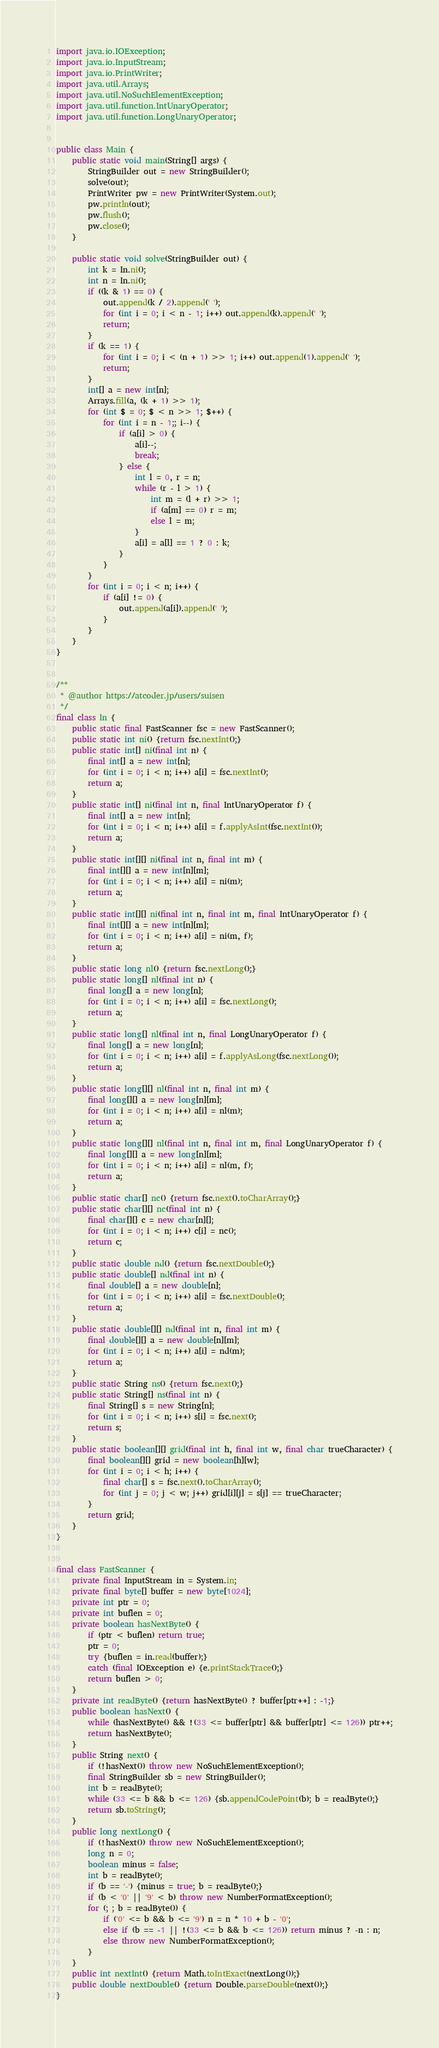Convert code to text. <code><loc_0><loc_0><loc_500><loc_500><_Java_>import java.io.IOException;
import java.io.InputStream;
import java.io.PrintWriter;
import java.util.Arrays;
import java.util.NoSuchElementException;
import java.util.function.IntUnaryOperator;
import java.util.function.LongUnaryOperator;


public class Main {
    public static void main(String[] args) {
        StringBuilder out = new StringBuilder();
        solve(out);
        PrintWriter pw = new PrintWriter(System.out);
        pw.println(out);
        pw.flush();
        pw.close();
    }

    public static void solve(StringBuilder out) {
        int k = In.ni();
        int n = In.ni();
        if ((k & 1) == 0) {
            out.append(k / 2).append(' ');
            for (int i = 0; i < n - 1; i++) out.append(k).append(' ');
            return;
        }
        if (k == 1) {
            for (int i = 0; i < (n + 1) >> 1; i++) out.append(1).append(' ');
            return;
        }
        int[] a = new int[n];
        Arrays.fill(a, (k + 1) >> 1);
        for (int $ = 0; $ < n >> 1; $++) {
            for (int i = n - 1;; i--) {
                if (a[i] > 0) {
                    a[i]--;
                    break;
                } else {
                    int l = 0, r = n;
                    while (r - l > 1) {
                        int m = (l + r) >> 1;
                        if (a[m] == 0) r = m;
                        else l = m;
                    }
                    a[i] = a[l] == 1 ? 0 : k;
                }
            }
        }
        for (int i = 0; i < n; i++) {
            if (a[i] != 0) {
                out.append(a[i]).append(' ');
            }
        }
    }
}


/**
 * @author https://atcoder.jp/users/suisen
 */
final class In {
    public static final FastScanner fsc = new FastScanner();
    public static int ni() {return fsc.nextInt();}
    public static int[] ni(final int n) {
        final int[] a = new int[n];
        for (int i = 0; i < n; i++) a[i] = fsc.nextInt();
        return a;
    }
    public static int[] ni(final int n, final IntUnaryOperator f) {
        final int[] a = new int[n];
        for (int i = 0; i < n; i++) a[i] = f.applyAsInt(fsc.nextInt());
        return a;
    }
    public static int[][] ni(final int n, final int m) {
        final int[][] a = new int[n][m];
        for (int i = 0; i < n; i++) a[i] = ni(m);
        return a;
    }
    public static int[][] ni(final int n, final int m, final IntUnaryOperator f) {
        final int[][] a = new int[n][m];
        for (int i = 0; i < n; i++) a[i] = ni(m, f);
        return a;
    }
    public static long nl() {return fsc.nextLong();}
    public static long[] nl(final int n) {
        final long[] a = new long[n];
        for (int i = 0; i < n; i++) a[i] = fsc.nextLong();
        return a;
    }
    public static long[] nl(final int n, final LongUnaryOperator f) {
        final long[] a = new long[n];
        for (int i = 0; i < n; i++) a[i] = f.applyAsLong(fsc.nextLong());
        return a;
    }
    public static long[][] nl(final int n, final int m) {
        final long[][] a = new long[n][m];
        for (int i = 0; i < n; i++) a[i] = nl(m);
        return a;
    }
    public static long[][] nl(final int n, final int m, final LongUnaryOperator f) {
        final long[][] a = new long[n][m];
        for (int i = 0; i < n; i++) a[i] = nl(m, f);
        return a;
    }
    public static char[] nc() {return fsc.next().toCharArray();}
    public static char[][] nc(final int n) {
        final char[][] c = new char[n][];
        for (int i = 0; i < n; i++) c[i] = nc();
        return c;
    }
    public static double nd() {return fsc.nextDouble();}
    public static double[] nd(final int n) {
        final double[] a = new double[n];
        for (int i = 0; i < n; i++) a[i] = fsc.nextDouble();
        return a;
    }
    public static double[][] nd(final int n, final int m) {
        final double[][] a = new double[n][m];
        for (int i = 0; i < n; i++) a[i] = nd(m);
        return a;
    }
    public static String ns() {return fsc.next();}
    public static String[] ns(final int n) {
        final String[] s = new String[n];
        for (int i = 0; i < n; i++) s[i] = fsc.next();
        return s;
    }
    public static boolean[][] grid(final int h, final int w, final char trueCharacter) {
        final boolean[][] grid = new boolean[h][w];
        for (int i = 0; i < h; i++) {
            final char[] s = fsc.next().toCharArray();
            for (int j = 0; j < w; j++) grid[i][j] = s[j] == trueCharacter;
        }
        return grid;
    }
}


final class FastScanner {
    private final InputStream in = System.in;
    private final byte[] buffer = new byte[1024];
    private int ptr = 0;
    private int buflen = 0;
    private boolean hasNextByte() {
        if (ptr < buflen) return true;
        ptr = 0;
        try {buflen = in.read(buffer);}
        catch (final IOException e) {e.printStackTrace();}
        return buflen > 0;
    }
    private int readByte() {return hasNextByte() ? buffer[ptr++] : -1;}
    public boolean hasNext() {
        while (hasNextByte() && !(33 <= buffer[ptr] && buffer[ptr] <= 126)) ptr++;
        return hasNextByte();
    }
    public String next() {
        if (!hasNext()) throw new NoSuchElementException();
        final StringBuilder sb = new StringBuilder();
        int b = readByte();
        while (33 <= b && b <= 126) {sb.appendCodePoint(b); b = readByte();}
        return sb.toString();
    }
    public long nextLong() {
        if (!hasNext()) throw new NoSuchElementException();
        long n = 0;
        boolean minus = false;
        int b = readByte();
        if (b == '-') {minus = true; b = readByte();}
        if (b < '0' || '9' < b) throw new NumberFormatException();
        for (; ; b = readByte()) {
            if ('0' <= b && b <= '9') n = n * 10 + b - '0';
            else if (b == -1 || !(33 <= b && b <= 126)) return minus ? -n : n;
            else throw new NumberFormatException();
        }
    }
    public int nextInt() {return Math.toIntExact(nextLong());}
    public double nextDouble() {return Double.parseDouble(next());}
}
</code> 